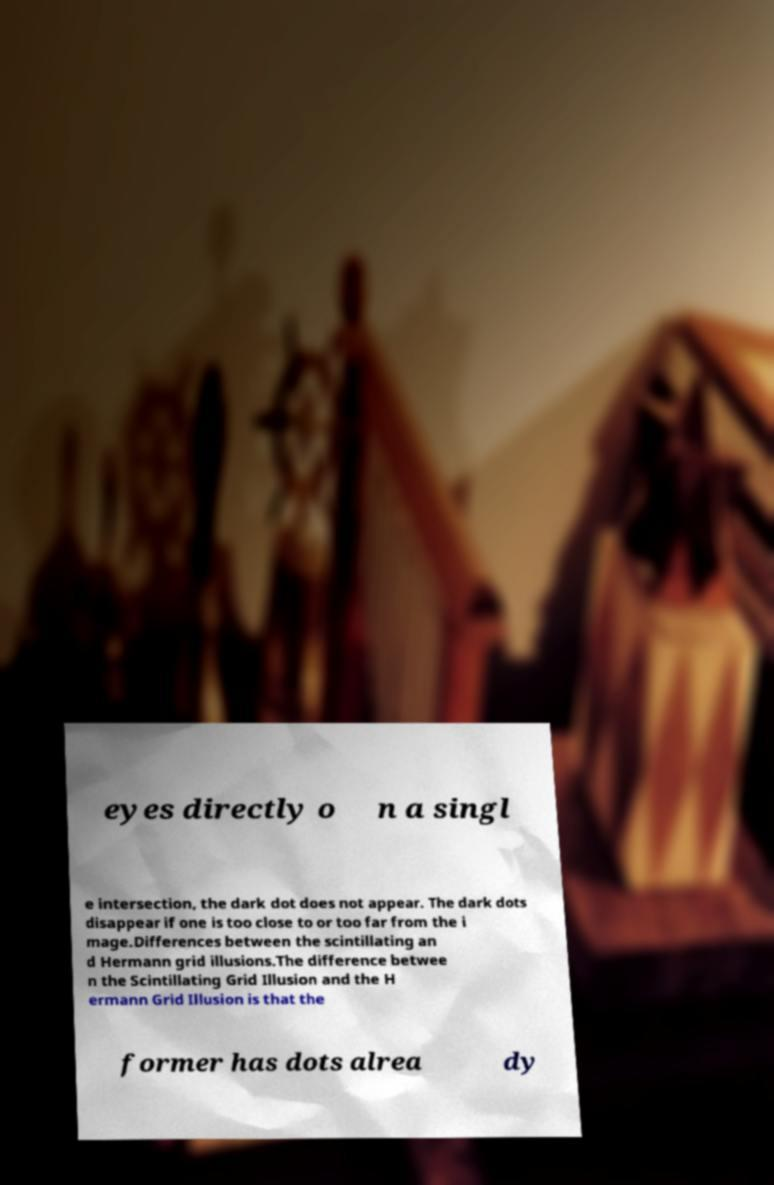What messages or text are displayed in this image? I need them in a readable, typed format. eyes directly o n a singl e intersection, the dark dot does not appear. The dark dots disappear if one is too close to or too far from the i mage.Differences between the scintillating an d Hermann grid illusions.The difference betwee n the Scintillating Grid Illusion and the H ermann Grid Illusion is that the former has dots alrea dy 